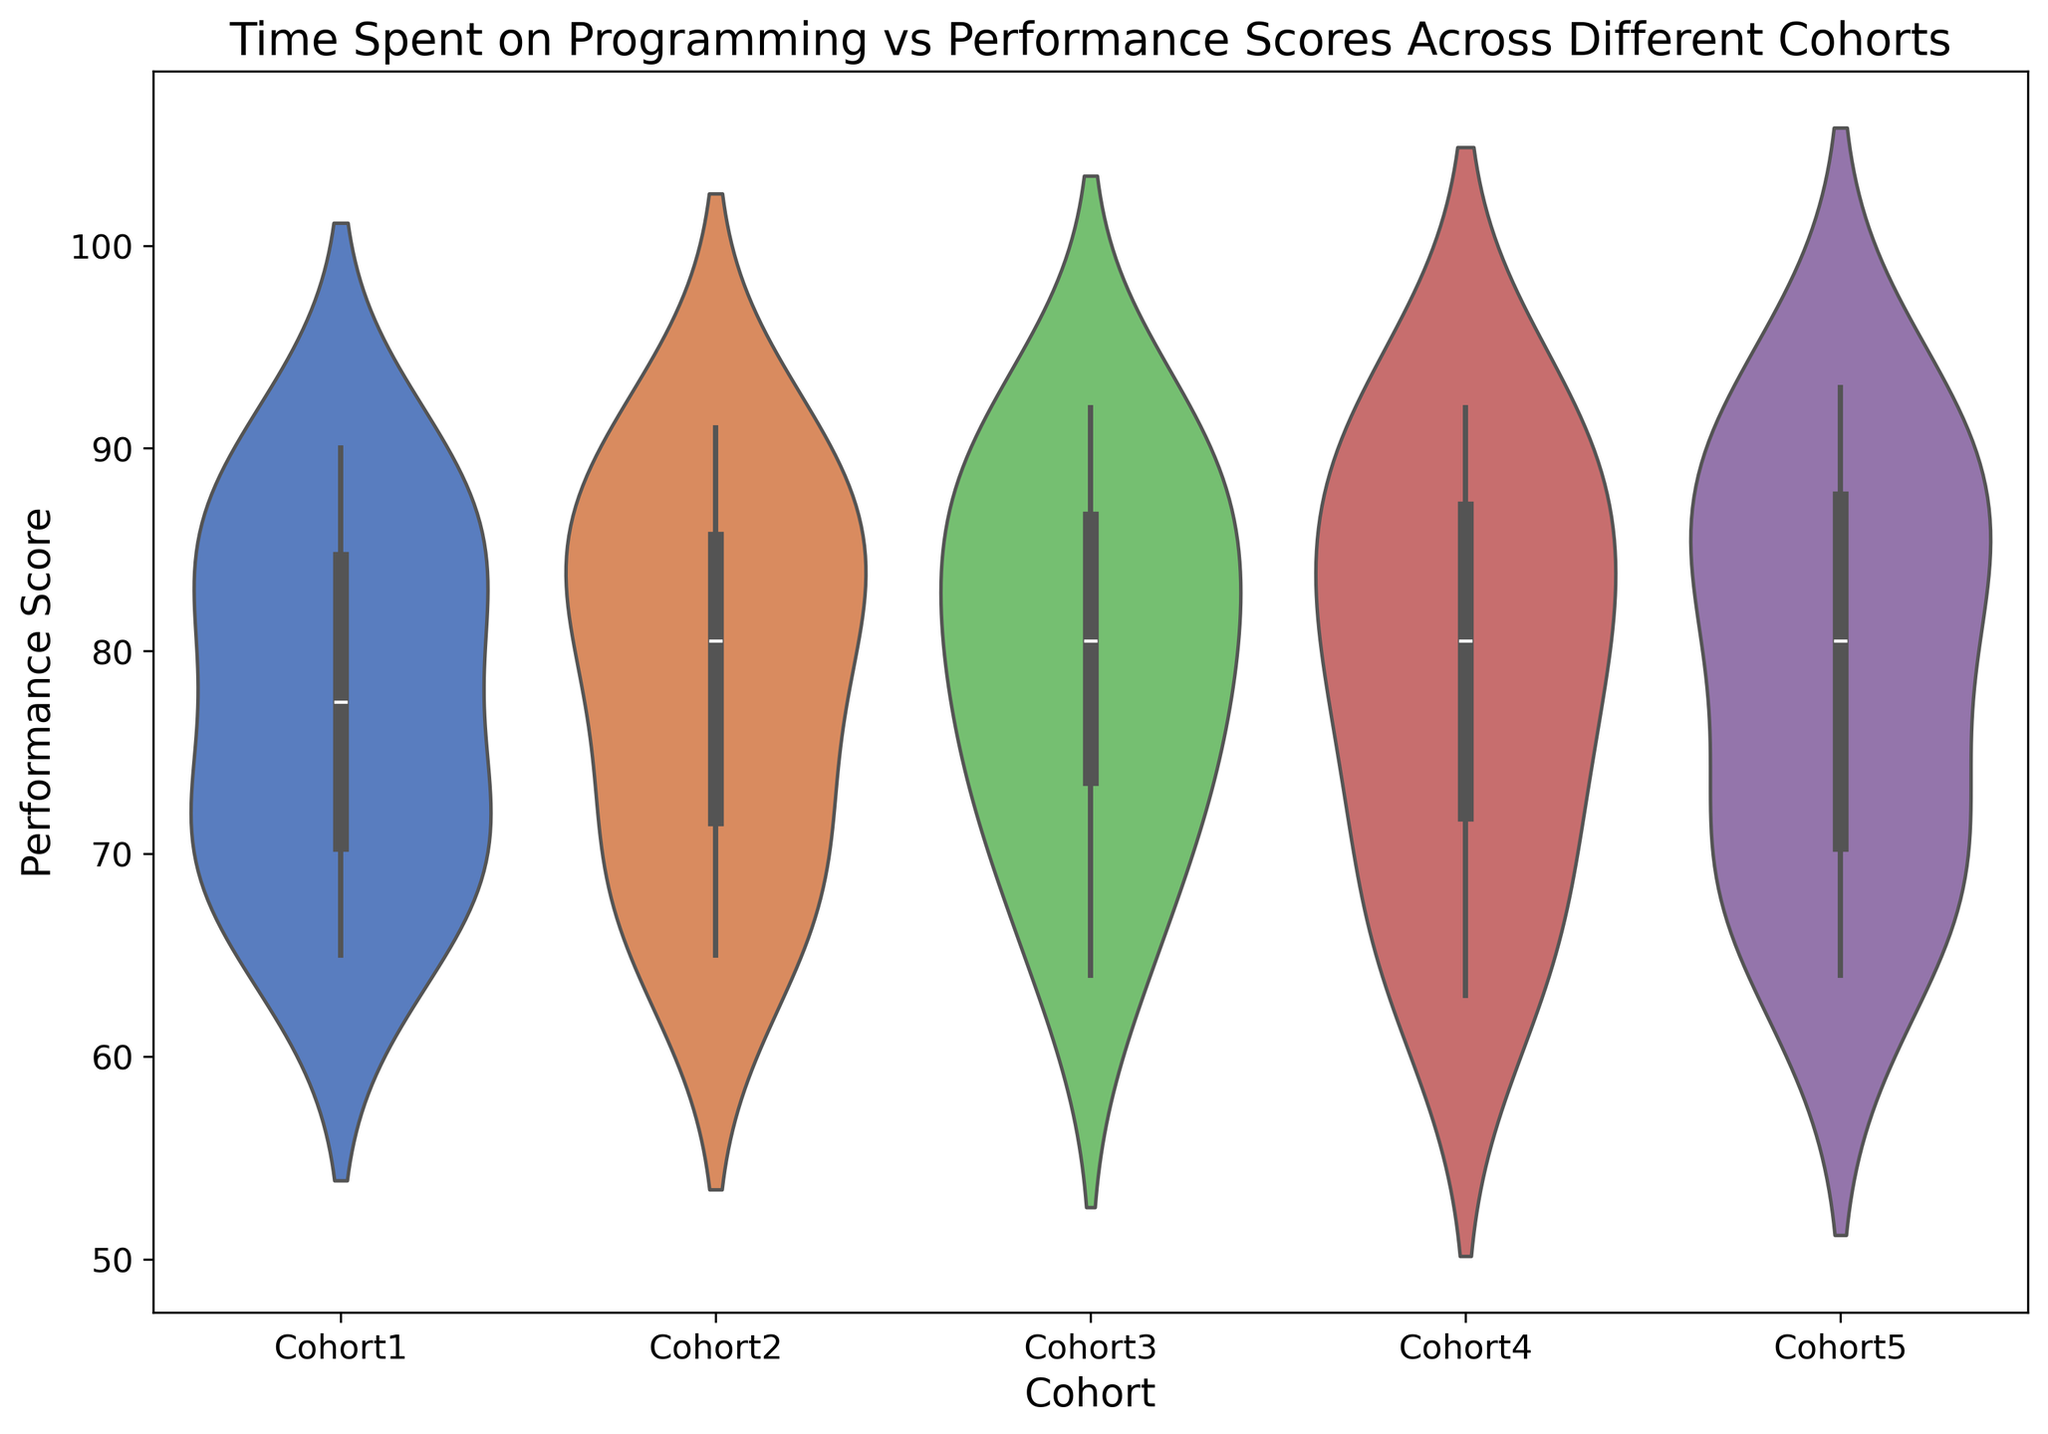Which cohort shows the highest median performance score? To identify the highest median performance score, look at the central tendency (thickest part) of the violin plots for each cohort. The cohort with the thickest part at the highest value on the y-axis is the one with the highest median score.
Answer: Cohort 5 Which cohort has the widest range of performance scores? Examine the vertical span of each violin plot. The cohort whose violin plot extends the most on the y-axis has the widest range of performance scores.
Answer: Cohort 3 Is Cohort 2's median performance score greater than Cohort 4's median performance score? Compare the central tendency of both violins. Look at the thickness of the distribution for each cohort. If the thickest part of Cohort 2's violin plot is higher on the y-axis than Cohort 4's thickest part, the median is greater.
Answer: No Which cohort has the smallest range of performance scores? Identify the cohort with the smallest vertical span of its violin plot. This will indicate the smallest range of performance scores.
Answer: Cohort 1 Between Cohort 3 and Cohort 5, which one has a higher median performance score? Observe the central thickest part of the violin plots for both cohorts. The cohort with the thicker part at a higher position on the y-axis has a higher median score.
Answer: Cohort 5 What is the median performance score range among all cohorts? Locate the thickest parts of all the violin plots to find the minimum and maximum median values. Subtract the minimum median value from the maximum median value to get the range.
Answer: 82 to 90 Which cohort shows the most skewed performance score distribution? Examine the symmetry of the violin plots. The more skewed distribution will have a noticeable bulge on one side, either at the top or bottom, compared to the other cohorts.
Answer: Cohort 4 Do any cohorts have outliers in their performance scores? Look for small dots or marks outside of the main body of the violin plots, indicating outliers. Outliers are extreme values that differ significantly from the rest of the data.
Answer: No 